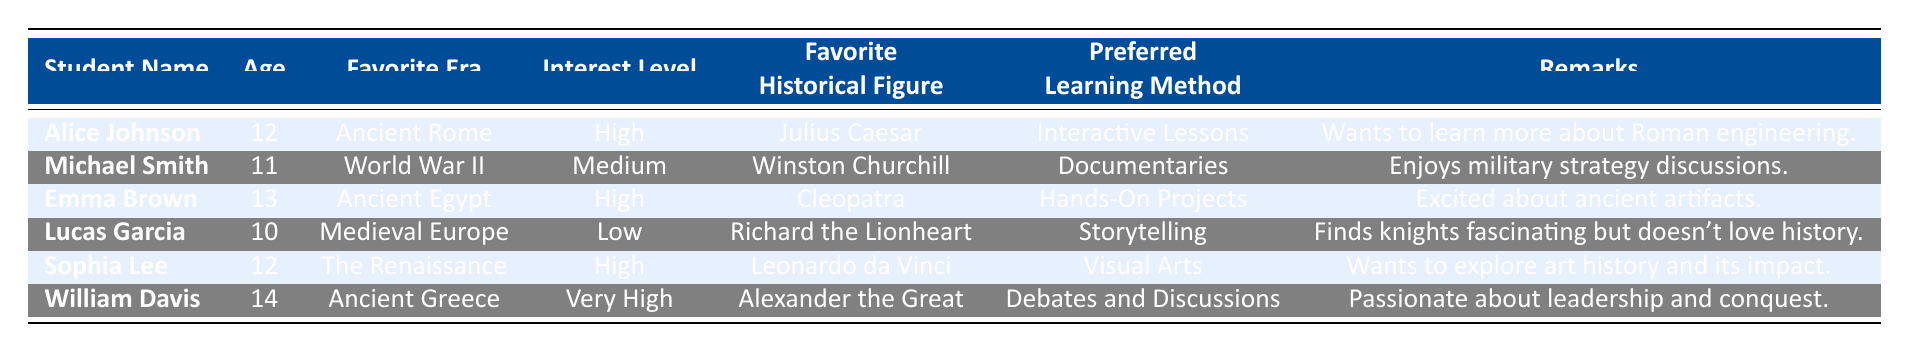What is the favorite historical figure of Emma Brown? According to the table, Emma Brown's favorite historical figure is Cleopatra.
Answer: Cleopatra How many students have a high interest level? The table lists three students with a high interest level: Alice Johnson, Emma Brown, and Sophia Lee.
Answer: 3 Which learning method does William Davis prefer? The table indicates that William Davis prefers debates and discussions as his learning method.
Answer: Debates and Discussions Is there a student who finds knights fascinating but doesn't love history? Yes, the table shows that Lucas Garcia finds knights fascinating but has a low interest level in history.
Answer: Yes What is the age of the student who has a very high interest level? William Davis, the student with a very high interest level, is 14 years old according to the table.
Answer: 14 Which era does Sophia Lee favor? According to the table, Sophia Lee favors The Renaissance as her favorite era.
Answer: The Renaissance How many students mentioned wanting to learn more about their favorite historical area? Alice Johnson wants to learn more about Roman engineering, while Sophia Lee wants to explore art history. Hence, there are two students.
Answer: 2 What is the average age of the students with high or very high interest levels? Alice Johnson (12), Emma Brown (13), Sophia Lee (12), and William Davis (14) have high or very high interest levels. The average age is (12 + 13 + 12 + 14) / 4 = 13.25.
Answer: 13.25 Who is the favorite historical figure of the student with the lowest interest level? Lucas Garcia, who has the lowest interest level, lists Richard the Lionheart as his favorite historical figure.
Answer: Richard the Lionheart Are there more students interested in ancient civilizations than in modern history? The table shows three students interested in ancient civilizations (Alice, Emma, William) and one student interested in modern history (Michael). So, yes, there are more students interested in ancient civilizations.
Answer: Yes 